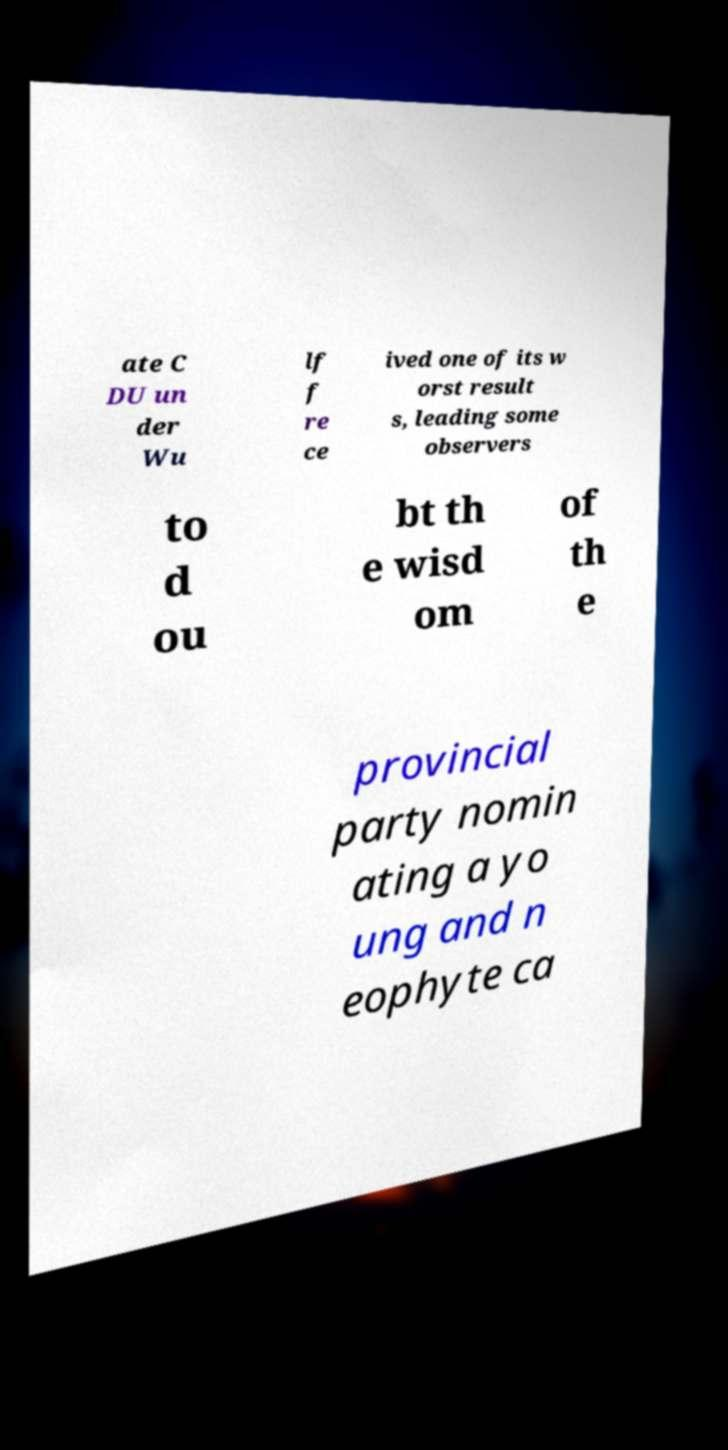Please read and relay the text visible in this image. What does it say? ate C DU un der Wu lf f re ce ived one of its w orst result s, leading some observers to d ou bt th e wisd om of th e provincial party nomin ating a yo ung and n eophyte ca 